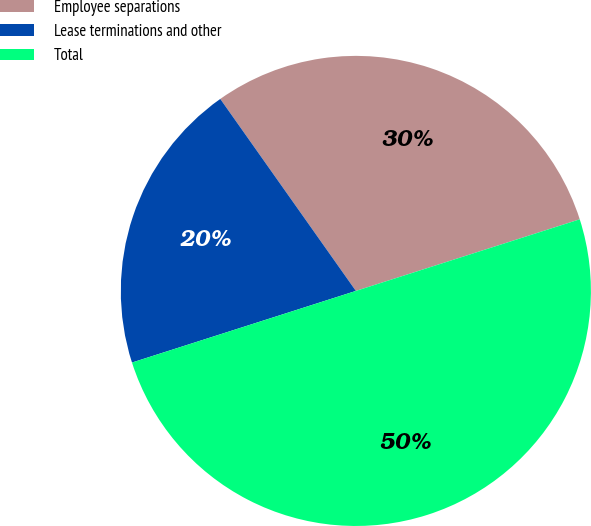<chart> <loc_0><loc_0><loc_500><loc_500><pie_chart><fcel>Employee separations<fcel>Lease terminations and other<fcel>Total<nl><fcel>29.86%<fcel>20.14%<fcel>50.0%<nl></chart> 